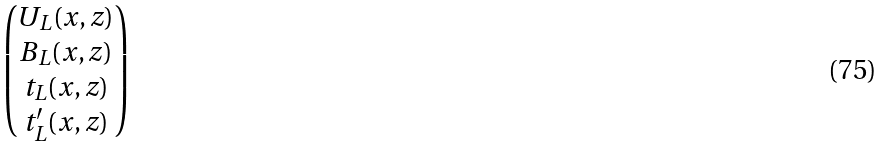<formula> <loc_0><loc_0><loc_500><loc_500>\begin{pmatrix} U _ { L } ( x , z ) \\ B _ { L } ( x , z ) \\ t _ { L } ( x , z ) \\ t ^ { \prime } _ { L } ( x , z ) \end{pmatrix}</formula> 